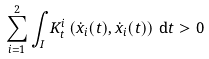<formula> <loc_0><loc_0><loc_500><loc_500>\sum _ { i = 1 } ^ { 2 } \int _ { I } K ^ { i } _ { t } \left ( \dot { x } _ { i } ( t ) , \dot { x } _ { i } ( t ) \right ) \, \mathrm d t > 0</formula> 